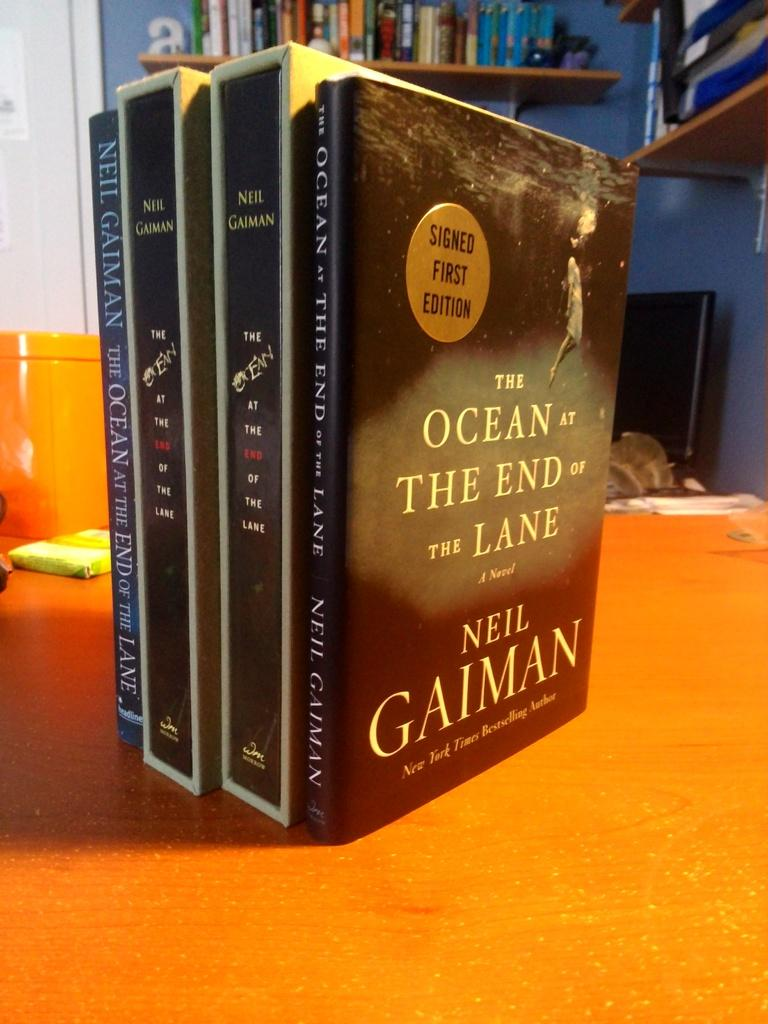<image>
Give a short and clear explanation of the subsequent image. table with four neil gaiman books standing upright on it 